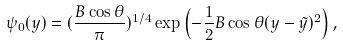Convert formula to latex. <formula><loc_0><loc_0><loc_500><loc_500>\psi _ { 0 } ( y ) = ( \frac { B \cos \theta } { \pi } ) ^ { 1 / 4 } \exp \left ( - \frac { 1 } { 2 } B \cos \theta ( y - \tilde { y } ) ^ { 2 } \right ) ,</formula> 